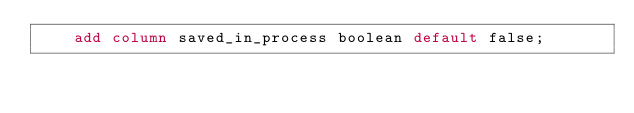Convert code to text. <code><loc_0><loc_0><loc_500><loc_500><_SQL_>    add column saved_in_process boolean default false;</code> 